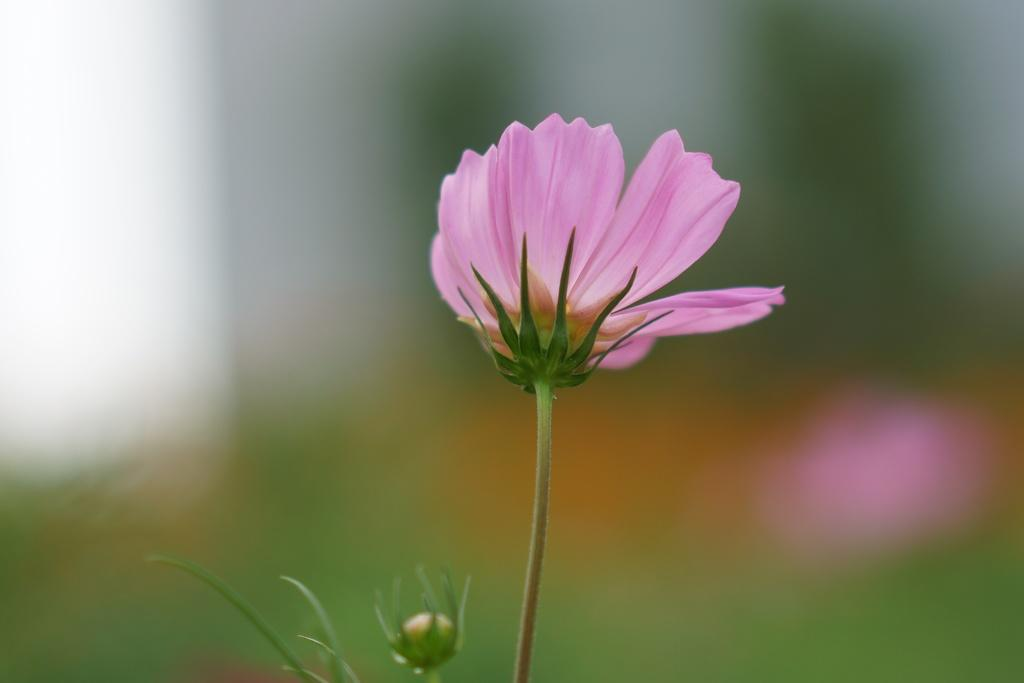What type of flower is present in the image? There is a pink color flower in the image. Can you describe any specific features of the flower? The flower has a stem. What type of plastic material is used to make the flower in the image? The flower in the image is not made of plastic; it is a real flower. What color is the light illuminating the flower in the image? There is no mention of a light source in the image, so it is not possible to determine the color of the light illuminating the flower. 